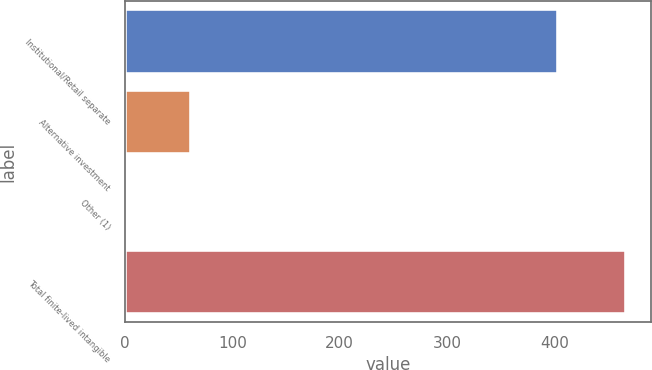<chart> <loc_0><loc_0><loc_500><loc_500><bar_chart><fcel>Institutional/Retail separate<fcel>Alternative investment<fcel>Other (1)<fcel>Total finite-lived intangible<nl><fcel>403<fcel>62<fcel>1<fcel>466<nl></chart> 